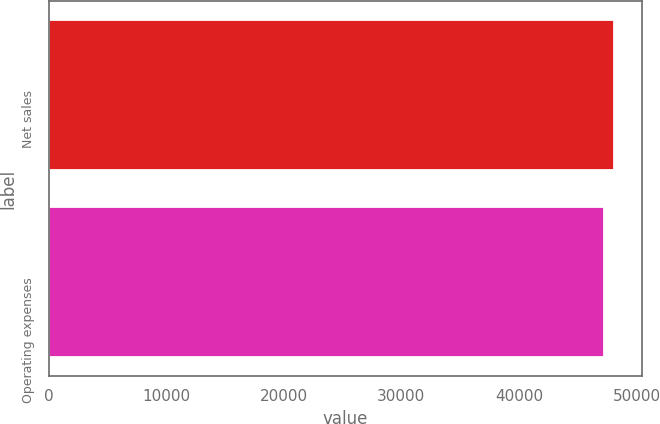Convert chart. <chart><loc_0><loc_0><loc_500><loc_500><bar_chart><fcel>Net sales<fcel>Operating expenses<nl><fcel>48077<fcel>47215<nl></chart> 